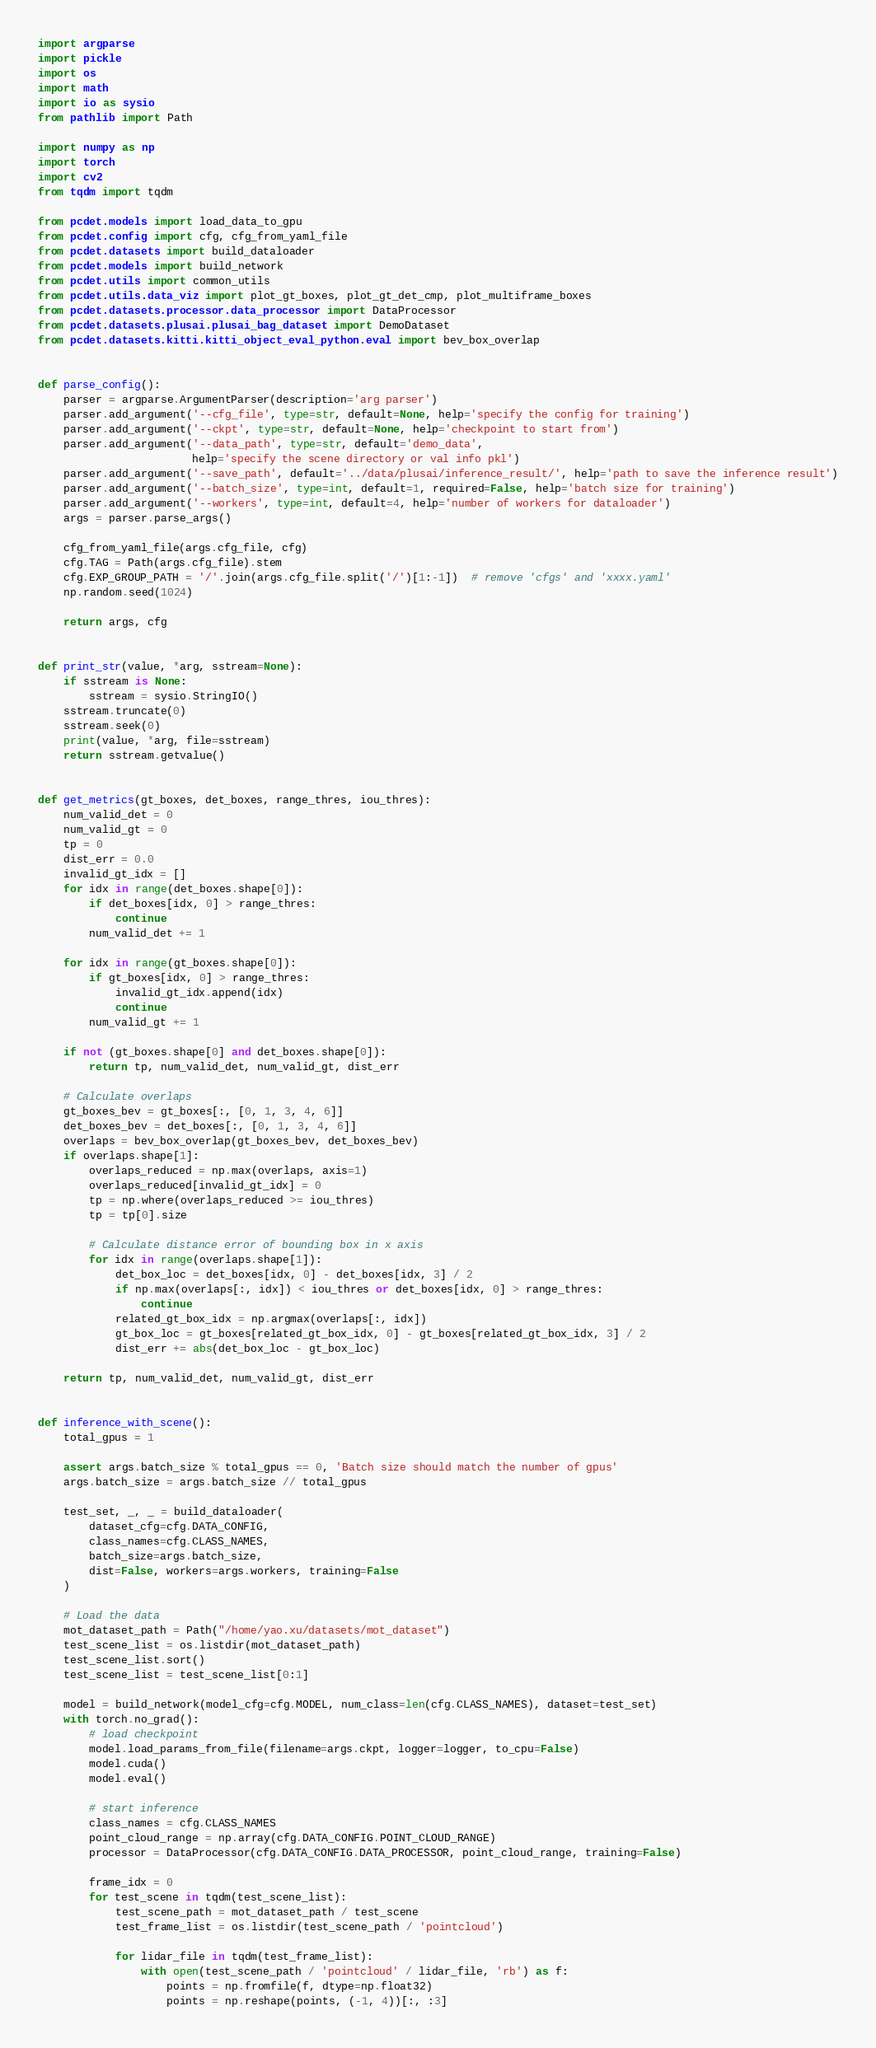<code> <loc_0><loc_0><loc_500><loc_500><_Python_>import argparse
import pickle
import os
import math
import io as sysio
from pathlib import Path

import numpy as np
import torch
import cv2
from tqdm import tqdm

from pcdet.models import load_data_to_gpu
from pcdet.config import cfg, cfg_from_yaml_file
from pcdet.datasets import build_dataloader
from pcdet.models import build_network
from pcdet.utils import common_utils
from pcdet.utils.data_viz import plot_gt_boxes, plot_gt_det_cmp, plot_multiframe_boxes
from pcdet.datasets.processor.data_processor import DataProcessor
from pcdet.datasets.plusai.plusai_bag_dataset import DemoDataset
from pcdet.datasets.kitti.kitti_object_eval_python.eval import bev_box_overlap


def parse_config():
    parser = argparse.ArgumentParser(description='arg parser')
    parser.add_argument('--cfg_file', type=str, default=None, help='specify the config for training')
    parser.add_argument('--ckpt', type=str, default=None, help='checkpoint to start from')
    parser.add_argument('--data_path', type=str, default='demo_data',
                        help='specify the scene directory or val info pkl')
    parser.add_argument('--save_path', default='../data/plusai/inference_result/', help='path to save the inference result')
    parser.add_argument('--batch_size', type=int, default=1, required=False, help='batch size for training')
    parser.add_argument('--workers', type=int, default=4, help='number of workers for dataloader')
    args = parser.parse_args()

    cfg_from_yaml_file(args.cfg_file, cfg)
    cfg.TAG = Path(args.cfg_file).stem
    cfg.EXP_GROUP_PATH = '/'.join(args.cfg_file.split('/')[1:-1])  # remove 'cfgs' and 'xxxx.yaml'
    np.random.seed(1024)

    return args, cfg


def print_str(value, *arg, sstream=None):
    if sstream is None:
        sstream = sysio.StringIO()
    sstream.truncate(0)
    sstream.seek(0)
    print(value, *arg, file=sstream)
    return sstream.getvalue()


def get_metrics(gt_boxes, det_boxes, range_thres, iou_thres):
    num_valid_det = 0
    num_valid_gt = 0
    tp = 0
    dist_err = 0.0
    invalid_gt_idx = []
    for idx in range(det_boxes.shape[0]):
        if det_boxes[idx, 0] > range_thres:
            continue
        num_valid_det += 1

    for idx in range(gt_boxes.shape[0]):
        if gt_boxes[idx, 0] > range_thres:
            invalid_gt_idx.append(idx)
            continue
        num_valid_gt += 1

    if not (gt_boxes.shape[0] and det_boxes.shape[0]):
        return tp, num_valid_det, num_valid_gt, dist_err

    # Calculate overlaps
    gt_boxes_bev = gt_boxes[:, [0, 1, 3, 4, 6]]
    det_boxes_bev = det_boxes[:, [0, 1, 3, 4, 6]]
    overlaps = bev_box_overlap(gt_boxes_bev, det_boxes_bev)
    if overlaps.shape[1]:
        overlaps_reduced = np.max(overlaps, axis=1)
        overlaps_reduced[invalid_gt_idx] = 0
        tp = np.where(overlaps_reduced >= iou_thres)
        tp = tp[0].size

        # Calculate distance error of bounding box in x axis
        for idx in range(overlaps.shape[1]):
            det_box_loc = det_boxes[idx, 0] - det_boxes[idx, 3] / 2
            if np.max(overlaps[:, idx]) < iou_thres or det_boxes[idx, 0] > range_thres:
                continue
            related_gt_box_idx = np.argmax(overlaps[:, idx])
            gt_box_loc = gt_boxes[related_gt_box_idx, 0] - gt_boxes[related_gt_box_idx, 3] / 2
            dist_err += abs(det_box_loc - gt_box_loc)

    return tp, num_valid_det, num_valid_gt, dist_err


def inference_with_scene():
    total_gpus = 1

    assert args.batch_size % total_gpus == 0, 'Batch size should match the number of gpus'
    args.batch_size = args.batch_size // total_gpus

    test_set, _, _ = build_dataloader(
        dataset_cfg=cfg.DATA_CONFIG,
        class_names=cfg.CLASS_NAMES,
        batch_size=args.batch_size,
        dist=False, workers=args.workers, training=False
    )

    # Load the data
    mot_dataset_path = Path("/home/yao.xu/datasets/mot_dataset")
    test_scene_list = os.listdir(mot_dataset_path)
    test_scene_list.sort()
    test_scene_list = test_scene_list[0:1]

    model = build_network(model_cfg=cfg.MODEL, num_class=len(cfg.CLASS_NAMES), dataset=test_set)
    with torch.no_grad():
        # load checkpoint
        model.load_params_from_file(filename=args.ckpt, logger=logger, to_cpu=False)
        model.cuda()
        model.eval()

        # start inference
        class_names = cfg.CLASS_NAMES
        point_cloud_range = np.array(cfg.DATA_CONFIG.POINT_CLOUD_RANGE)
        processor = DataProcessor(cfg.DATA_CONFIG.DATA_PROCESSOR, point_cloud_range, training=False)

        frame_idx = 0
        for test_scene in tqdm(test_scene_list):
            test_scene_path = mot_dataset_path / test_scene
            test_frame_list = os.listdir(test_scene_path / 'pointcloud')

            for lidar_file in tqdm(test_frame_list):
                with open(test_scene_path / 'pointcloud' / lidar_file, 'rb') as f:
                    points = np.fromfile(f, dtype=np.float32)
                    points = np.reshape(points, (-1, 4))[:, :3]</code> 